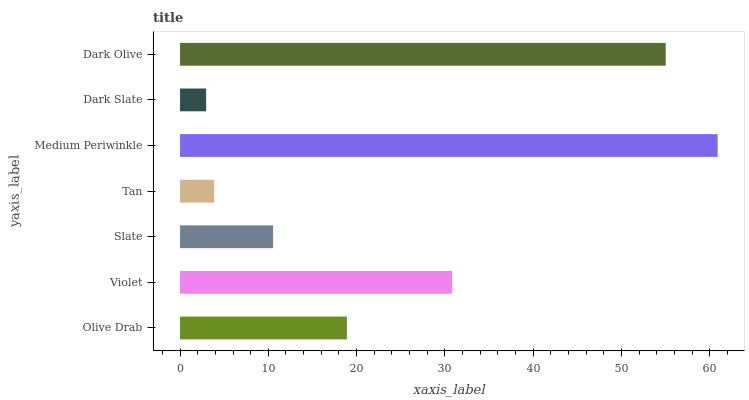Is Dark Slate the minimum?
Answer yes or no. Yes. Is Medium Periwinkle the maximum?
Answer yes or no. Yes. Is Violet the minimum?
Answer yes or no. No. Is Violet the maximum?
Answer yes or no. No. Is Violet greater than Olive Drab?
Answer yes or no. Yes. Is Olive Drab less than Violet?
Answer yes or no. Yes. Is Olive Drab greater than Violet?
Answer yes or no. No. Is Violet less than Olive Drab?
Answer yes or no. No. Is Olive Drab the high median?
Answer yes or no. Yes. Is Olive Drab the low median?
Answer yes or no. Yes. Is Dark Slate the high median?
Answer yes or no. No. Is Medium Periwinkle the low median?
Answer yes or no. No. 